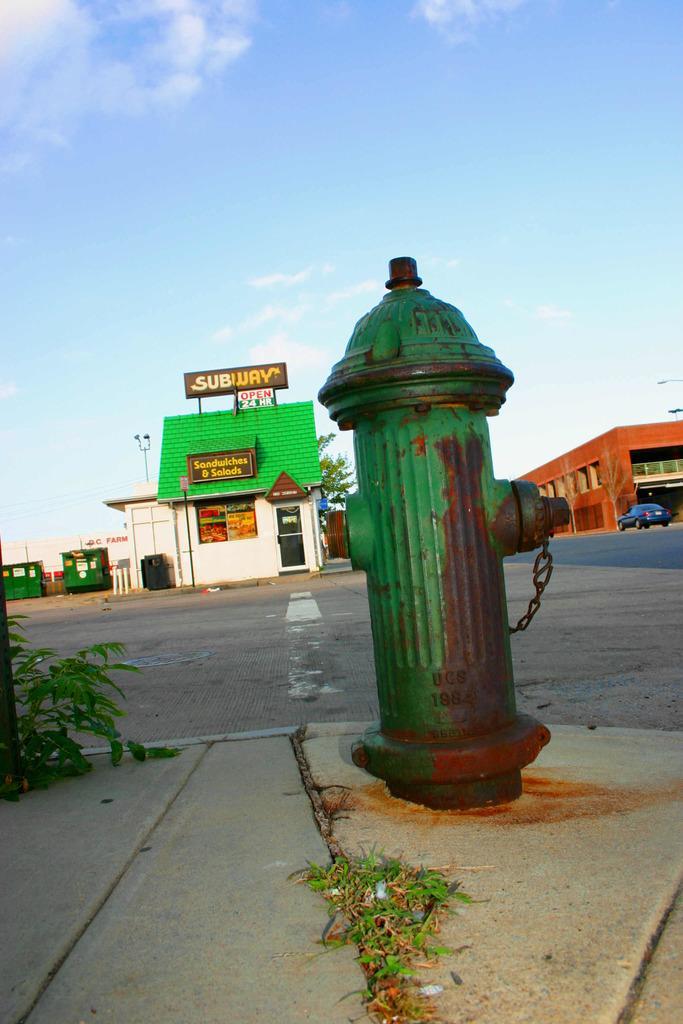Please provide a concise description of this image. In this image I can see the sidewalk, some grass on the sidewalk, a fire hydrant which is green and brown in color. In the background I can see the road, a car on the road, few buildings, a tree, few boards and the sky. 